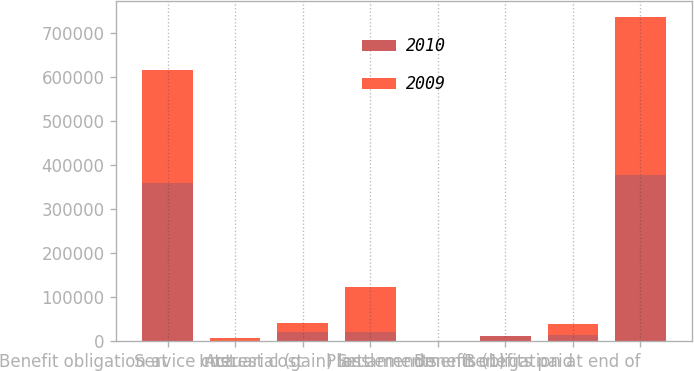<chart> <loc_0><loc_0><loc_500><loc_500><stacked_bar_chart><ecel><fcel>Benefit obligation at<fcel>Service cost<fcel>Interest cost<fcel>Actuarial (gain) loss<fcel>Settlements<fcel>Plan amendments (1)<fcel>Benefits paid<fcel>Benefit obligation at end of<nl><fcel>2010<fcel>359167<fcel>0<fcel>20858<fcel>20994<fcel>826<fcel>10882<fcel>13020<fcel>376291<nl><fcel>2009<fcel>256414<fcel>6430<fcel>20189<fcel>101410<fcel>204<fcel>0<fcel>25072<fcel>359167<nl></chart> 